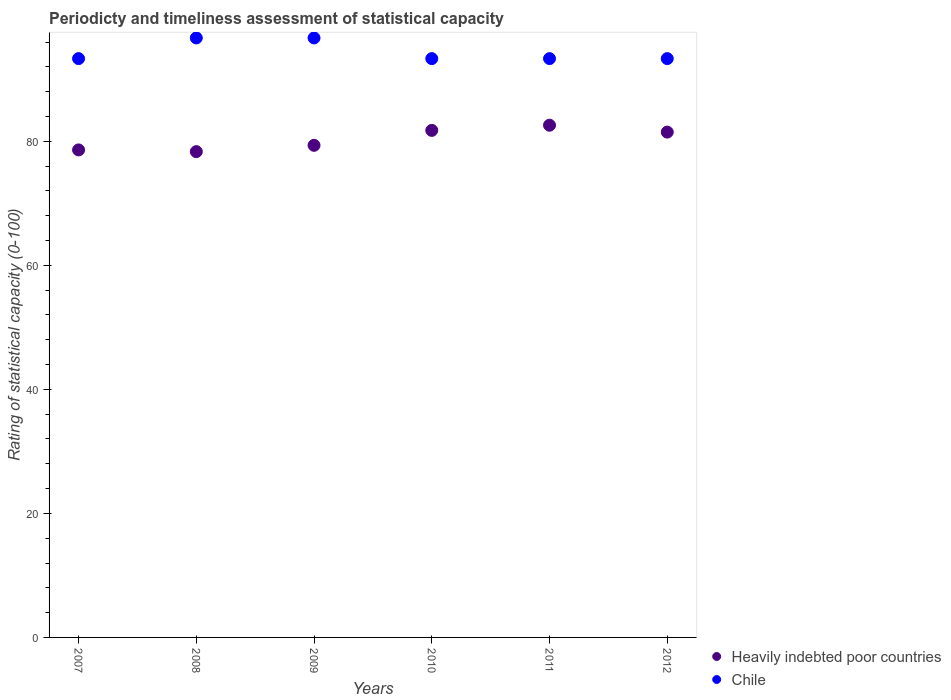How many different coloured dotlines are there?
Offer a very short reply. 2. Is the number of dotlines equal to the number of legend labels?
Your response must be concise. Yes. What is the rating of statistical capacity in Chile in 2010?
Offer a terse response. 93.33. Across all years, what is the maximum rating of statistical capacity in Heavily indebted poor countries?
Ensure brevity in your answer.  82.59. Across all years, what is the minimum rating of statistical capacity in Heavily indebted poor countries?
Provide a short and direct response. 78.33. What is the total rating of statistical capacity in Chile in the graph?
Make the answer very short. 566.67. What is the difference between the rating of statistical capacity in Heavily indebted poor countries in 2009 and that in 2011?
Your answer should be compact. -3.24. What is the difference between the rating of statistical capacity in Heavily indebted poor countries in 2012 and the rating of statistical capacity in Chile in 2008?
Offer a very short reply. -15.19. What is the average rating of statistical capacity in Chile per year?
Make the answer very short. 94.44. In the year 2012, what is the difference between the rating of statistical capacity in Heavily indebted poor countries and rating of statistical capacity in Chile?
Your answer should be compact. -11.85. What is the ratio of the rating of statistical capacity in Chile in 2008 to that in 2010?
Give a very brief answer. 1.04. Is the difference between the rating of statistical capacity in Heavily indebted poor countries in 2007 and 2009 greater than the difference between the rating of statistical capacity in Chile in 2007 and 2009?
Give a very brief answer. Yes. What is the difference between the highest and the second highest rating of statistical capacity in Heavily indebted poor countries?
Offer a terse response. 0.83. What is the difference between the highest and the lowest rating of statistical capacity in Chile?
Offer a very short reply. 3.33. In how many years, is the rating of statistical capacity in Chile greater than the average rating of statistical capacity in Chile taken over all years?
Your answer should be very brief. 2. Is the sum of the rating of statistical capacity in Chile in 2010 and 2012 greater than the maximum rating of statistical capacity in Heavily indebted poor countries across all years?
Keep it short and to the point. Yes. Does the rating of statistical capacity in Chile monotonically increase over the years?
Offer a very short reply. No. Is the rating of statistical capacity in Heavily indebted poor countries strictly greater than the rating of statistical capacity in Chile over the years?
Your answer should be very brief. No. Is the rating of statistical capacity in Heavily indebted poor countries strictly less than the rating of statistical capacity in Chile over the years?
Your response must be concise. Yes. How many dotlines are there?
Your answer should be very brief. 2. Does the graph contain any zero values?
Make the answer very short. No. Where does the legend appear in the graph?
Give a very brief answer. Bottom right. What is the title of the graph?
Give a very brief answer. Periodicty and timeliness assessment of statistical capacity. What is the label or title of the X-axis?
Offer a terse response. Years. What is the label or title of the Y-axis?
Your answer should be compact. Rating of statistical capacity (0-100). What is the Rating of statistical capacity (0-100) in Heavily indebted poor countries in 2007?
Provide a short and direct response. 78.61. What is the Rating of statistical capacity (0-100) in Chile in 2007?
Provide a succinct answer. 93.33. What is the Rating of statistical capacity (0-100) in Heavily indebted poor countries in 2008?
Keep it short and to the point. 78.33. What is the Rating of statistical capacity (0-100) of Chile in 2008?
Offer a terse response. 96.67. What is the Rating of statistical capacity (0-100) in Heavily indebted poor countries in 2009?
Offer a terse response. 79.35. What is the Rating of statistical capacity (0-100) in Chile in 2009?
Your answer should be very brief. 96.67. What is the Rating of statistical capacity (0-100) of Heavily indebted poor countries in 2010?
Ensure brevity in your answer.  81.76. What is the Rating of statistical capacity (0-100) of Chile in 2010?
Keep it short and to the point. 93.33. What is the Rating of statistical capacity (0-100) of Heavily indebted poor countries in 2011?
Offer a terse response. 82.59. What is the Rating of statistical capacity (0-100) in Chile in 2011?
Give a very brief answer. 93.33. What is the Rating of statistical capacity (0-100) in Heavily indebted poor countries in 2012?
Offer a terse response. 81.48. What is the Rating of statistical capacity (0-100) of Chile in 2012?
Keep it short and to the point. 93.33. Across all years, what is the maximum Rating of statistical capacity (0-100) in Heavily indebted poor countries?
Your response must be concise. 82.59. Across all years, what is the maximum Rating of statistical capacity (0-100) in Chile?
Your response must be concise. 96.67. Across all years, what is the minimum Rating of statistical capacity (0-100) in Heavily indebted poor countries?
Make the answer very short. 78.33. Across all years, what is the minimum Rating of statistical capacity (0-100) in Chile?
Your answer should be compact. 93.33. What is the total Rating of statistical capacity (0-100) in Heavily indebted poor countries in the graph?
Offer a very short reply. 482.13. What is the total Rating of statistical capacity (0-100) in Chile in the graph?
Provide a succinct answer. 566.67. What is the difference between the Rating of statistical capacity (0-100) in Heavily indebted poor countries in 2007 and that in 2008?
Provide a succinct answer. 0.28. What is the difference between the Rating of statistical capacity (0-100) in Chile in 2007 and that in 2008?
Give a very brief answer. -3.33. What is the difference between the Rating of statistical capacity (0-100) in Heavily indebted poor countries in 2007 and that in 2009?
Your response must be concise. -0.74. What is the difference between the Rating of statistical capacity (0-100) of Chile in 2007 and that in 2009?
Make the answer very short. -3.33. What is the difference between the Rating of statistical capacity (0-100) of Heavily indebted poor countries in 2007 and that in 2010?
Offer a very short reply. -3.15. What is the difference between the Rating of statistical capacity (0-100) of Chile in 2007 and that in 2010?
Your answer should be very brief. 0. What is the difference between the Rating of statistical capacity (0-100) in Heavily indebted poor countries in 2007 and that in 2011?
Offer a terse response. -3.98. What is the difference between the Rating of statistical capacity (0-100) in Chile in 2007 and that in 2011?
Ensure brevity in your answer.  0. What is the difference between the Rating of statistical capacity (0-100) in Heavily indebted poor countries in 2007 and that in 2012?
Provide a short and direct response. -2.87. What is the difference between the Rating of statistical capacity (0-100) in Heavily indebted poor countries in 2008 and that in 2009?
Provide a succinct answer. -1.02. What is the difference between the Rating of statistical capacity (0-100) of Heavily indebted poor countries in 2008 and that in 2010?
Give a very brief answer. -3.43. What is the difference between the Rating of statistical capacity (0-100) in Heavily indebted poor countries in 2008 and that in 2011?
Provide a short and direct response. -4.26. What is the difference between the Rating of statistical capacity (0-100) of Heavily indebted poor countries in 2008 and that in 2012?
Provide a short and direct response. -3.15. What is the difference between the Rating of statistical capacity (0-100) in Chile in 2008 and that in 2012?
Your response must be concise. 3.33. What is the difference between the Rating of statistical capacity (0-100) of Heavily indebted poor countries in 2009 and that in 2010?
Ensure brevity in your answer.  -2.41. What is the difference between the Rating of statistical capacity (0-100) of Chile in 2009 and that in 2010?
Keep it short and to the point. 3.33. What is the difference between the Rating of statistical capacity (0-100) in Heavily indebted poor countries in 2009 and that in 2011?
Keep it short and to the point. -3.24. What is the difference between the Rating of statistical capacity (0-100) of Chile in 2009 and that in 2011?
Provide a short and direct response. 3.33. What is the difference between the Rating of statistical capacity (0-100) in Heavily indebted poor countries in 2009 and that in 2012?
Your answer should be very brief. -2.13. What is the difference between the Rating of statistical capacity (0-100) in Chile in 2009 and that in 2012?
Provide a succinct answer. 3.33. What is the difference between the Rating of statistical capacity (0-100) in Heavily indebted poor countries in 2010 and that in 2011?
Make the answer very short. -0.83. What is the difference between the Rating of statistical capacity (0-100) of Heavily indebted poor countries in 2010 and that in 2012?
Offer a terse response. 0.28. What is the difference between the Rating of statistical capacity (0-100) in Heavily indebted poor countries in 2007 and the Rating of statistical capacity (0-100) in Chile in 2008?
Keep it short and to the point. -18.06. What is the difference between the Rating of statistical capacity (0-100) of Heavily indebted poor countries in 2007 and the Rating of statistical capacity (0-100) of Chile in 2009?
Keep it short and to the point. -18.06. What is the difference between the Rating of statistical capacity (0-100) of Heavily indebted poor countries in 2007 and the Rating of statistical capacity (0-100) of Chile in 2010?
Your response must be concise. -14.72. What is the difference between the Rating of statistical capacity (0-100) of Heavily indebted poor countries in 2007 and the Rating of statistical capacity (0-100) of Chile in 2011?
Your answer should be very brief. -14.72. What is the difference between the Rating of statistical capacity (0-100) of Heavily indebted poor countries in 2007 and the Rating of statistical capacity (0-100) of Chile in 2012?
Provide a succinct answer. -14.72. What is the difference between the Rating of statistical capacity (0-100) in Heavily indebted poor countries in 2008 and the Rating of statistical capacity (0-100) in Chile in 2009?
Your answer should be compact. -18.33. What is the difference between the Rating of statistical capacity (0-100) of Heavily indebted poor countries in 2008 and the Rating of statistical capacity (0-100) of Chile in 2010?
Keep it short and to the point. -15. What is the difference between the Rating of statistical capacity (0-100) in Heavily indebted poor countries in 2008 and the Rating of statistical capacity (0-100) in Chile in 2012?
Your response must be concise. -15. What is the difference between the Rating of statistical capacity (0-100) in Heavily indebted poor countries in 2009 and the Rating of statistical capacity (0-100) in Chile in 2010?
Keep it short and to the point. -13.98. What is the difference between the Rating of statistical capacity (0-100) of Heavily indebted poor countries in 2009 and the Rating of statistical capacity (0-100) of Chile in 2011?
Offer a terse response. -13.98. What is the difference between the Rating of statistical capacity (0-100) of Heavily indebted poor countries in 2009 and the Rating of statistical capacity (0-100) of Chile in 2012?
Your answer should be very brief. -13.98. What is the difference between the Rating of statistical capacity (0-100) of Heavily indebted poor countries in 2010 and the Rating of statistical capacity (0-100) of Chile in 2011?
Offer a very short reply. -11.57. What is the difference between the Rating of statistical capacity (0-100) in Heavily indebted poor countries in 2010 and the Rating of statistical capacity (0-100) in Chile in 2012?
Make the answer very short. -11.57. What is the difference between the Rating of statistical capacity (0-100) of Heavily indebted poor countries in 2011 and the Rating of statistical capacity (0-100) of Chile in 2012?
Make the answer very short. -10.74. What is the average Rating of statistical capacity (0-100) of Heavily indebted poor countries per year?
Your answer should be compact. 80.35. What is the average Rating of statistical capacity (0-100) in Chile per year?
Your answer should be very brief. 94.44. In the year 2007, what is the difference between the Rating of statistical capacity (0-100) in Heavily indebted poor countries and Rating of statistical capacity (0-100) in Chile?
Give a very brief answer. -14.72. In the year 2008, what is the difference between the Rating of statistical capacity (0-100) in Heavily indebted poor countries and Rating of statistical capacity (0-100) in Chile?
Provide a succinct answer. -18.33. In the year 2009, what is the difference between the Rating of statistical capacity (0-100) in Heavily indebted poor countries and Rating of statistical capacity (0-100) in Chile?
Your answer should be compact. -17.31. In the year 2010, what is the difference between the Rating of statistical capacity (0-100) in Heavily indebted poor countries and Rating of statistical capacity (0-100) in Chile?
Give a very brief answer. -11.57. In the year 2011, what is the difference between the Rating of statistical capacity (0-100) in Heavily indebted poor countries and Rating of statistical capacity (0-100) in Chile?
Your response must be concise. -10.74. In the year 2012, what is the difference between the Rating of statistical capacity (0-100) in Heavily indebted poor countries and Rating of statistical capacity (0-100) in Chile?
Your response must be concise. -11.85. What is the ratio of the Rating of statistical capacity (0-100) of Heavily indebted poor countries in 2007 to that in 2008?
Keep it short and to the point. 1. What is the ratio of the Rating of statistical capacity (0-100) of Chile in 2007 to that in 2008?
Give a very brief answer. 0.97. What is the ratio of the Rating of statistical capacity (0-100) in Chile in 2007 to that in 2009?
Your response must be concise. 0.97. What is the ratio of the Rating of statistical capacity (0-100) of Heavily indebted poor countries in 2007 to that in 2010?
Your answer should be compact. 0.96. What is the ratio of the Rating of statistical capacity (0-100) in Heavily indebted poor countries in 2007 to that in 2011?
Make the answer very short. 0.95. What is the ratio of the Rating of statistical capacity (0-100) in Heavily indebted poor countries in 2007 to that in 2012?
Make the answer very short. 0.96. What is the ratio of the Rating of statistical capacity (0-100) in Chile in 2007 to that in 2012?
Offer a terse response. 1. What is the ratio of the Rating of statistical capacity (0-100) of Heavily indebted poor countries in 2008 to that in 2009?
Offer a terse response. 0.99. What is the ratio of the Rating of statistical capacity (0-100) in Heavily indebted poor countries in 2008 to that in 2010?
Give a very brief answer. 0.96. What is the ratio of the Rating of statistical capacity (0-100) of Chile in 2008 to that in 2010?
Ensure brevity in your answer.  1.04. What is the ratio of the Rating of statistical capacity (0-100) in Heavily indebted poor countries in 2008 to that in 2011?
Ensure brevity in your answer.  0.95. What is the ratio of the Rating of statistical capacity (0-100) of Chile in 2008 to that in 2011?
Make the answer very short. 1.04. What is the ratio of the Rating of statistical capacity (0-100) in Heavily indebted poor countries in 2008 to that in 2012?
Make the answer very short. 0.96. What is the ratio of the Rating of statistical capacity (0-100) in Chile in 2008 to that in 2012?
Make the answer very short. 1.04. What is the ratio of the Rating of statistical capacity (0-100) in Heavily indebted poor countries in 2009 to that in 2010?
Ensure brevity in your answer.  0.97. What is the ratio of the Rating of statistical capacity (0-100) of Chile in 2009 to that in 2010?
Provide a succinct answer. 1.04. What is the ratio of the Rating of statistical capacity (0-100) of Heavily indebted poor countries in 2009 to that in 2011?
Make the answer very short. 0.96. What is the ratio of the Rating of statistical capacity (0-100) of Chile in 2009 to that in 2011?
Offer a very short reply. 1.04. What is the ratio of the Rating of statistical capacity (0-100) in Heavily indebted poor countries in 2009 to that in 2012?
Your answer should be compact. 0.97. What is the ratio of the Rating of statistical capacity (0-100) in Chile in 2009 to that in 2012?
Your answer should be compact. 1.04. What is the ratio of the Rating of statistical capacity (0-100) of Heavily indebted poor countries in 2010 to that in 2011?
Your answer should be very brief. 0.99. What is the ratio of the Rating of statistical capacity (0-100) in Heavily indebted poor countries in 2010 to that in 2012?
Offer a very short reply. 1. What is the ratio of the Rating of statistical capacity (0-100) of Chile in 2010 to that in 2012?
Your response must be concise. 1. What is the ratio of the Rating of statistical capacity (0-100) in Heavily indebted poor countries in 2011 to that in 2012?
Give a very brief answer. 1.01. What is the ratio of the Rating of statistical capacity (0-100) in Chile in 2011 to that in 2012?
Your answer should be compact. 1. What is the difference between the highest and the second highest Rating of statistical capacity (0-100) in Heavily indebted poor countries?
Your answer should be compact. 0.83. What is the difference between the highest and the lowest Rating of statistical capacity (0-100) of Heavily indebted poor countries?
Offer a very short reply. 4.26. 